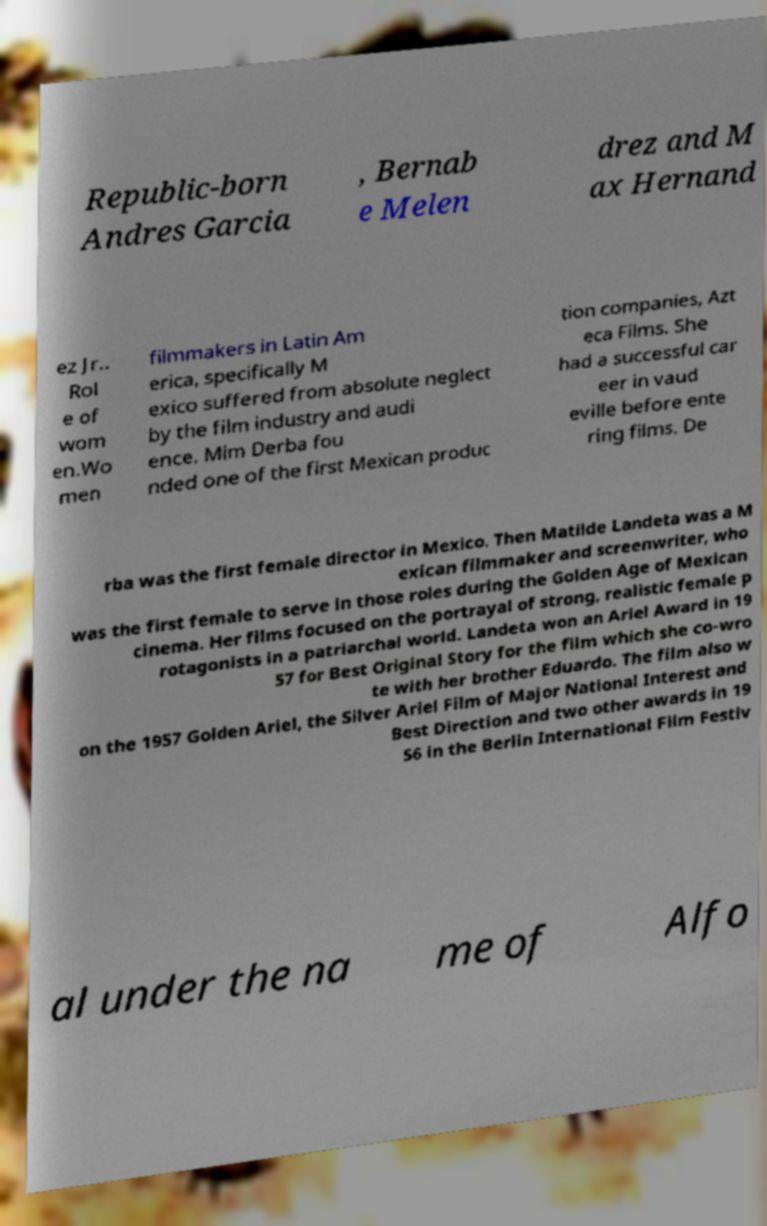Can you read and provide the text displayed in the image?This photo seems to have some interesting text. Can you extract and type it out for me? Republic-born Andres Garcia , Bernab e Melen drez and M ax Hernand ez Jr.. Rol e of wom en.Wo men filmmakers in Latin Am erica, specifically M exico suffered from absolute neglect by the film industry and audi ence. Mim Derba fou nded one of the first Mexican produc tion companies, Azt eca Films. She had a successful car eer in vaud eville before ente ring films. De rba was the first female director in Mexico. Then Matilde Landeta was a M exican filmmaker and screenwriter, who was the first female to serve in those roles during the Golden Age of Mexican cinema. Her films focused on the portrayal of strong, realistic female p rotagonists in a patriarchal world. Landeta won an Ariel Award in 19 57 for Best Original Story for the film which she co-wro te with her brother Eduardo. The film also w on the 1957 Golden Ariel, the Silver Ariel Film of Major National Interest and Best Direction and two other awards in 19 56 in the Berlin International Film Festiv al under the na me of Alfo 